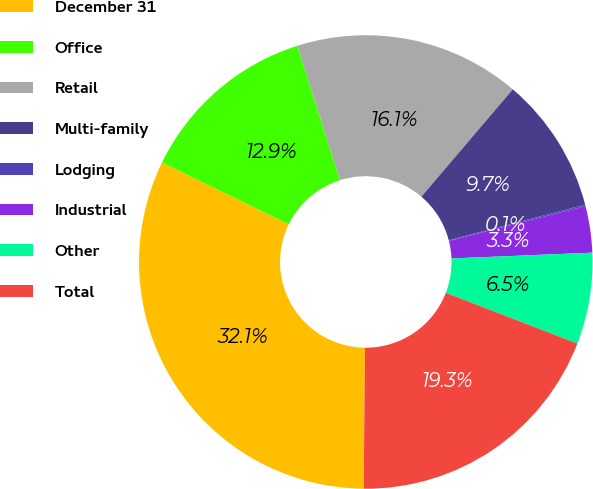<chart> <loc_0><loc_0><loc_500><loc_500><pie_chart><fcel>December 31<fcel>Office<fcel>Retail<fcel>Multi-family<fcel>Lodging<fcel>Industrial<fcel>Other<fcel>Total<nl><fcel>32.08%<fcel>12.9%<fcel>16.1%<fcel>9.7%<fcel>0.11%<fcel>3.31%<fcel>6.51%<fcel>19.29%<nl></chart> 